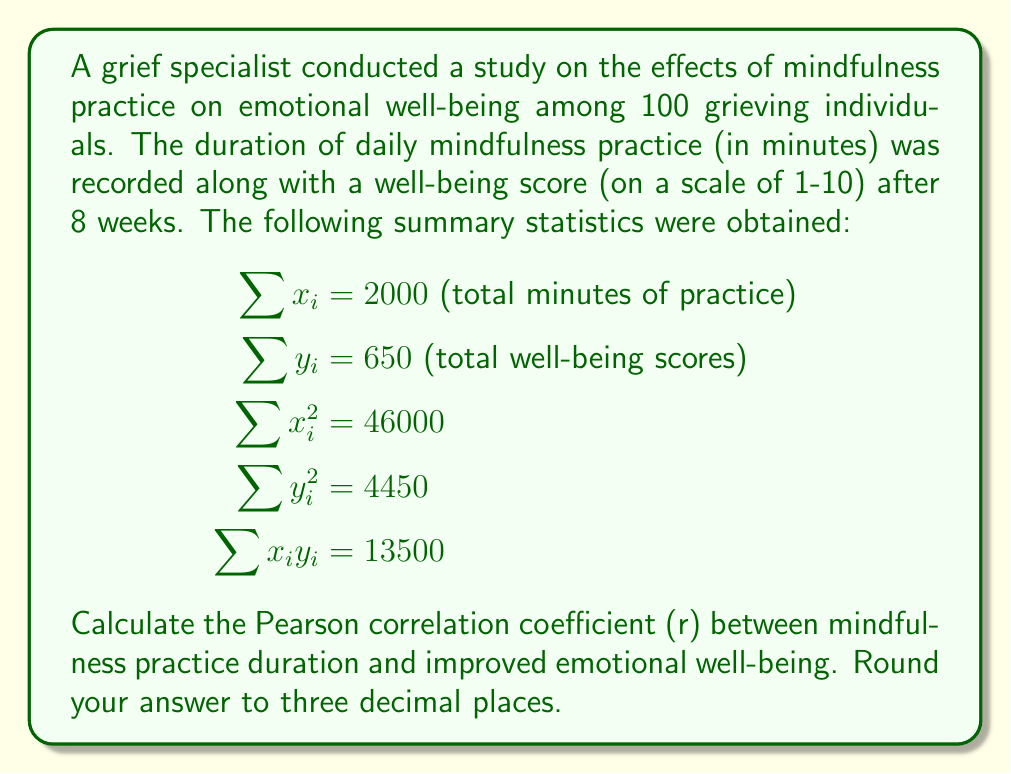Teach me how to tackle this problem. To calculate the Pearson correlation coefficient (r), we'll use the formula:

$$r = \frac{n\sum x_iy_i - \sum x_i \sum y_i}{\sqrt{[n\sum x_i^2 - (\sum x_i)^2][n\sum y_i^2 - (\sum y_i)^2]}}$$

Where:
n = number of participants = 100
$\sum x_i$ = total minutes of practice = 2000
$\sum y_i$ = total well-being scores = 650
$\sum x_i^2$ = 46000
$\sum y_i^2$ = 4450
$\sum x_iy_i$ = 13500

Let's solve step by step:

1) Calculate $n\sum x_iy_i$:
   $100 \times 13500 = 1350000$

2) Calculate $\sum x_i \sum y_i$:
   $2000 \times 650 = 1300000$

3) Calculate the numerator:
   $1350000 - 1300000 = 50000$

4) Calculate $n\sum x_i^2$:
   $100 \times 46000 = 4600000$

5) Calculate $(\sum x_i)^2$:
   $2000^2 = 4000000$

6) Calculate $n\sum y_i^2$:
   $100 \times 4450 = 445000$

7) Calculate $(\sum y_i)^2$:
   $650^2 = 422500$

8) Calculate the denominator:
   $\sqrt{[4600000 - 4000000][445000 - 422500]}$
   $= \sqrt{600000 \times 22500}$
   $= \sqrt{13500000000}$
   $= 116189.5$

9) Finally, calculate r:
   $r = \frac{50000}{116189.5} = 0.4303$

Rounding to three decimal places, we get 0.430.
Answer: 0.430 